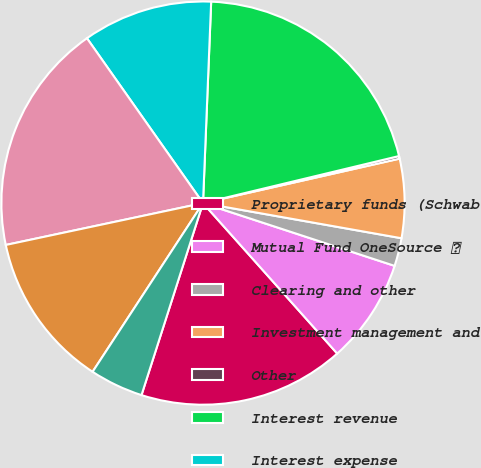<chart> <loc_0><loc_0><loc_500><loc_500><pie_chart><fcel>Proprietary funds (Schwab<fcel>Mutual Fund OneSource <fcel>Clearing and other<fcel>Investment management and<fcel>Other<fcel>Interest revenue<fcel>Interest expense<fcel>Net interest revenue<fcel>Commissions<fcel>Principal transactions<nl><fcel>16.53%<fcel>8.37%<fcel>2.25%<fcel>6.33%<fcel>0.21%<fcel>20.61%<fcel>10.41%<fcel>18.57%<fcel>12.45%<fcel>4.29%<nl></chart> 